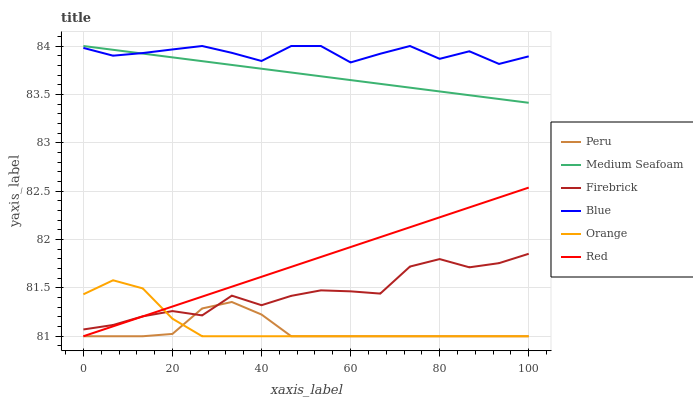Does Firebrick have the minimum area under the curve?
Answer yes or no. No. Does Firebrick have the maximum area under the curve?
Answer yes or no. No. Is Firebrick the smoothest?
Answer yes or no. No. Is Firebrick the roughest?
Answer yes or no. No. Does Firebrick have the lowest value?
Answer yes or no. No. Does Firebrick have the highest value?
Answer yes or no. No. Is Peru less than Blue?
Answer yes or no. Yes. Is Blue greater than Peru?
Answer yes or no. Yes. Does Peru intersect Blue?
Answer yes or no. No. 